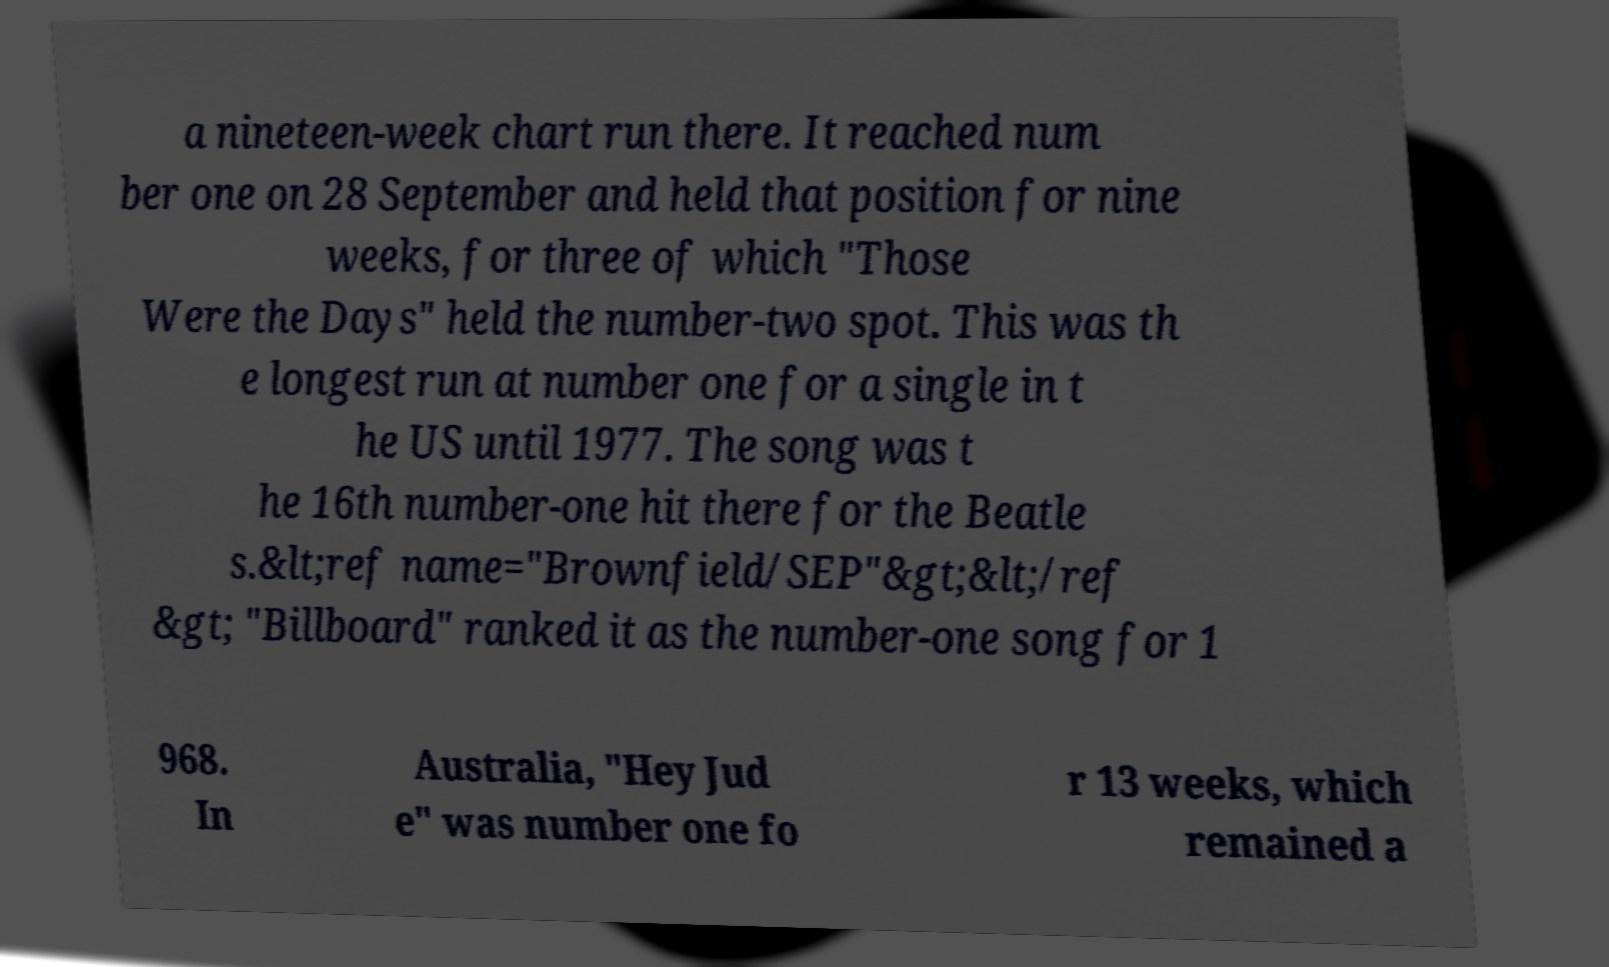I need the written content from this picture converted into text. Can you do that? a nineteen-week chart run there. It reached num ber one on 28 September and held that position for nine weeks, for three of which "Those Were the Days" held the number-two spot. This was th e longest run at number one for a single in t he US until 1977. The song was t he 16th number-one hit there for the Beatle s.&lt;ref name="Brownfield/SEP"&gt;&lt;/ref &gt; "Billboard" ranked it as the number-one song for 1 968. In Australia, "Hey Jud e" was number one fo r 13 weeks, which remained a 